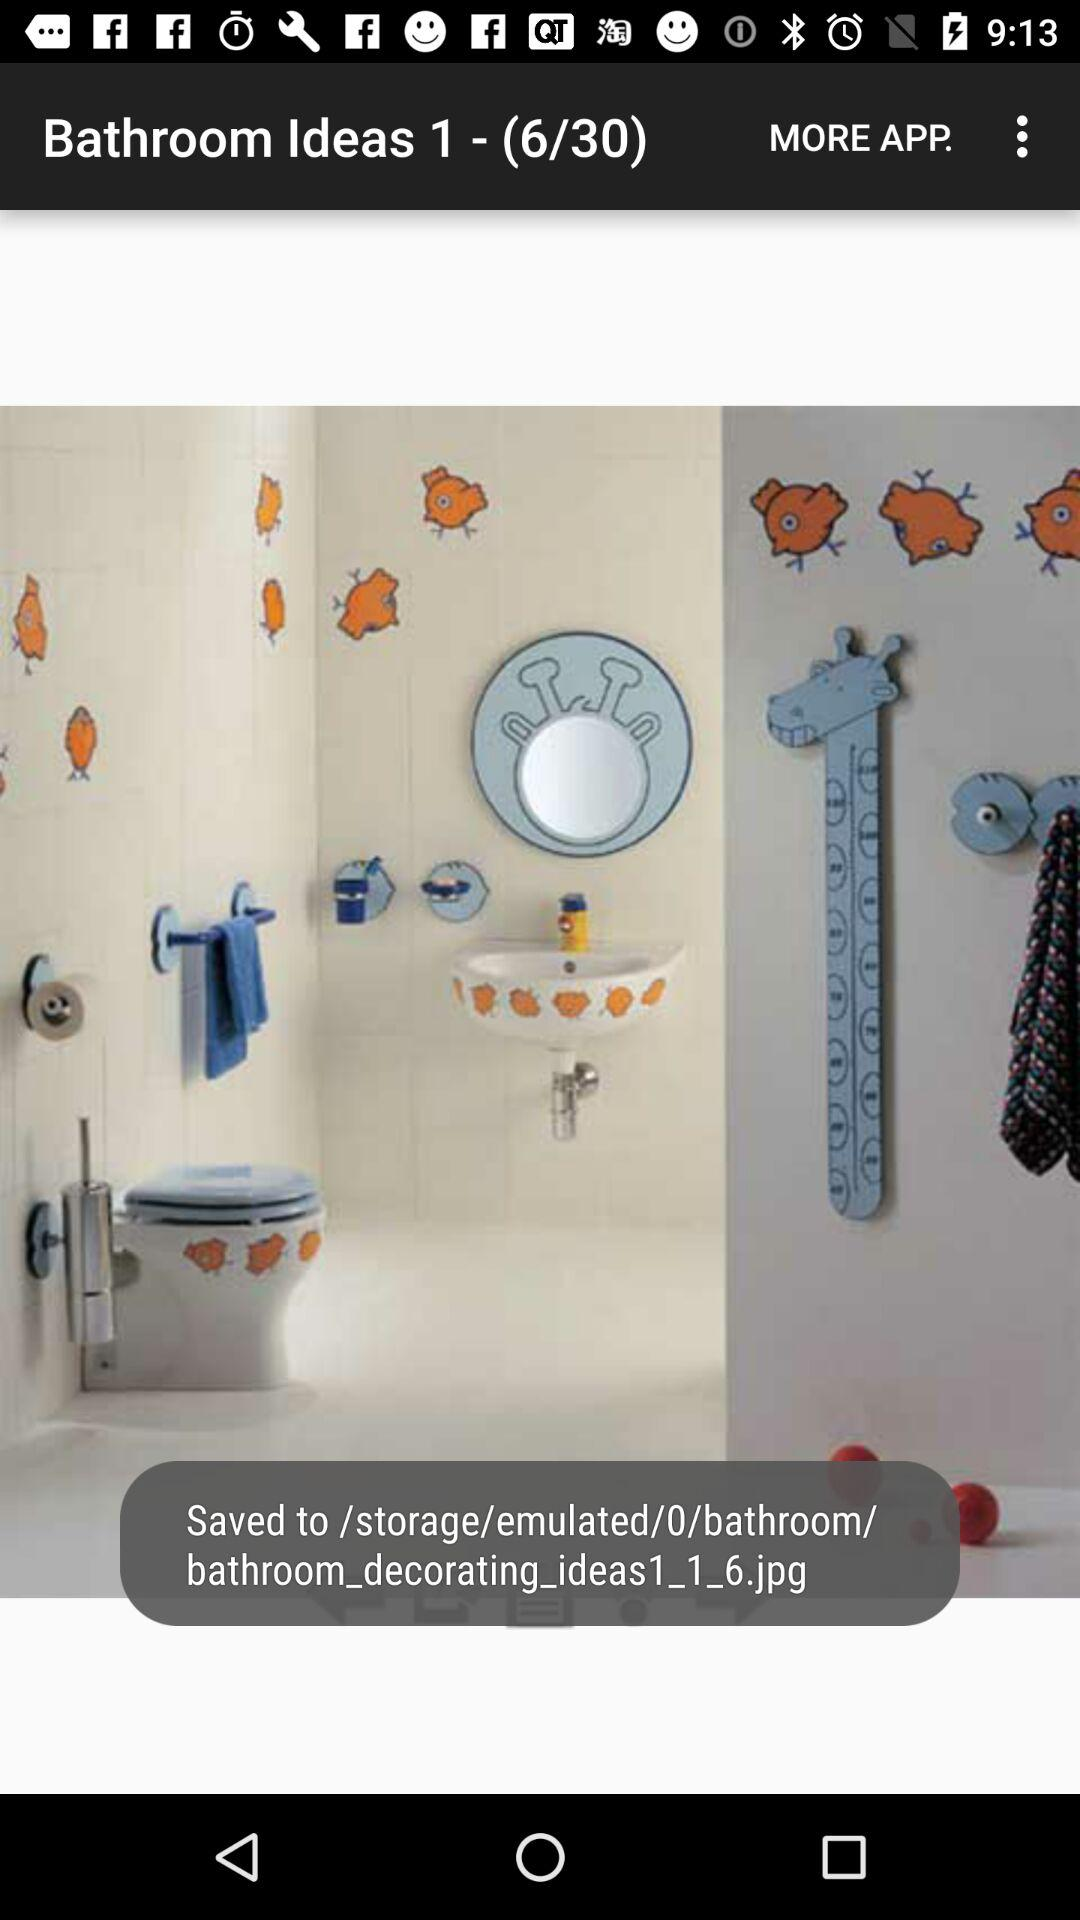What is the current image number? The current image number is 6. 